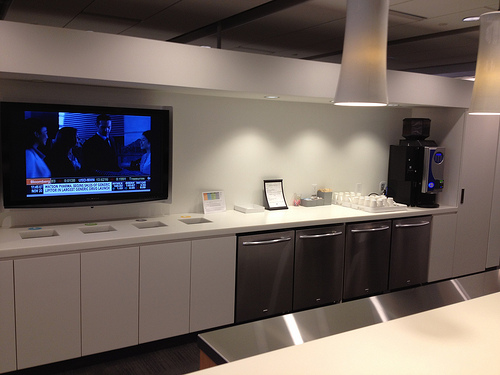Please provide a short description for this region: [0.02, 0.35, 0.38, 0.53]. This area depicts a television that is turned on. 